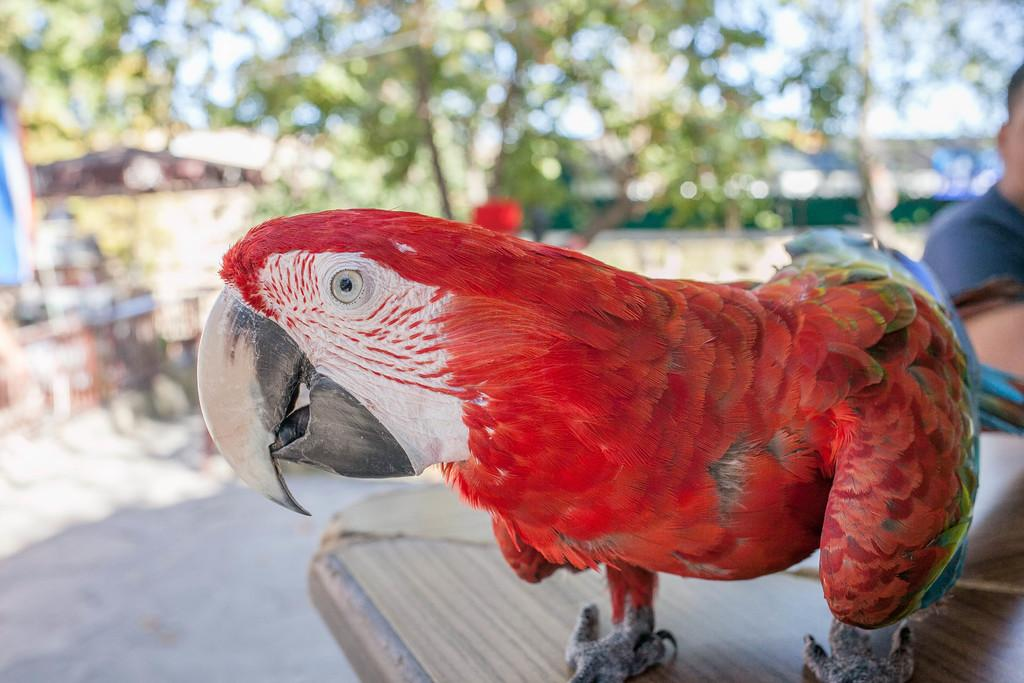What type of animal is in the image? There is a parrot in the image. Where is the parrot located? The parrot is on a table. What can be seen in the background of the image? There are trees in the background of the image. What is visible at the bottom of the image? The ground is visible at the bottom of the image. Who else is present in the image? There is a man sitting on the right side of the image. What type of library can be seen in the image? There is no library present in the image; it features a parrot on a table, trees in the background, and a man sitting on the right side. 